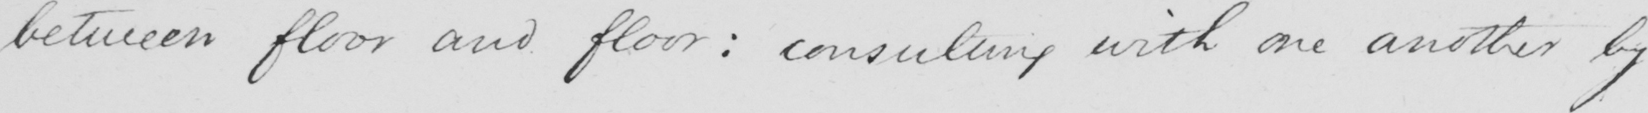What text is written in this handwritten line? between floor and floor consulting with one another by 